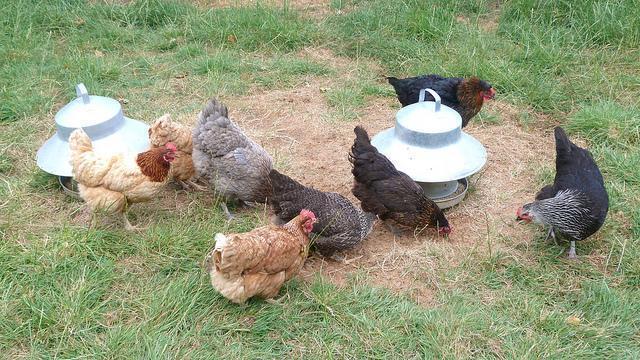How many brown chickens seen?
Give a very brief answer. 3. How many birds are in the picture?
Give a very brief answer. 7. How many people are wearing coats?
Give a very brief answer. 0. 